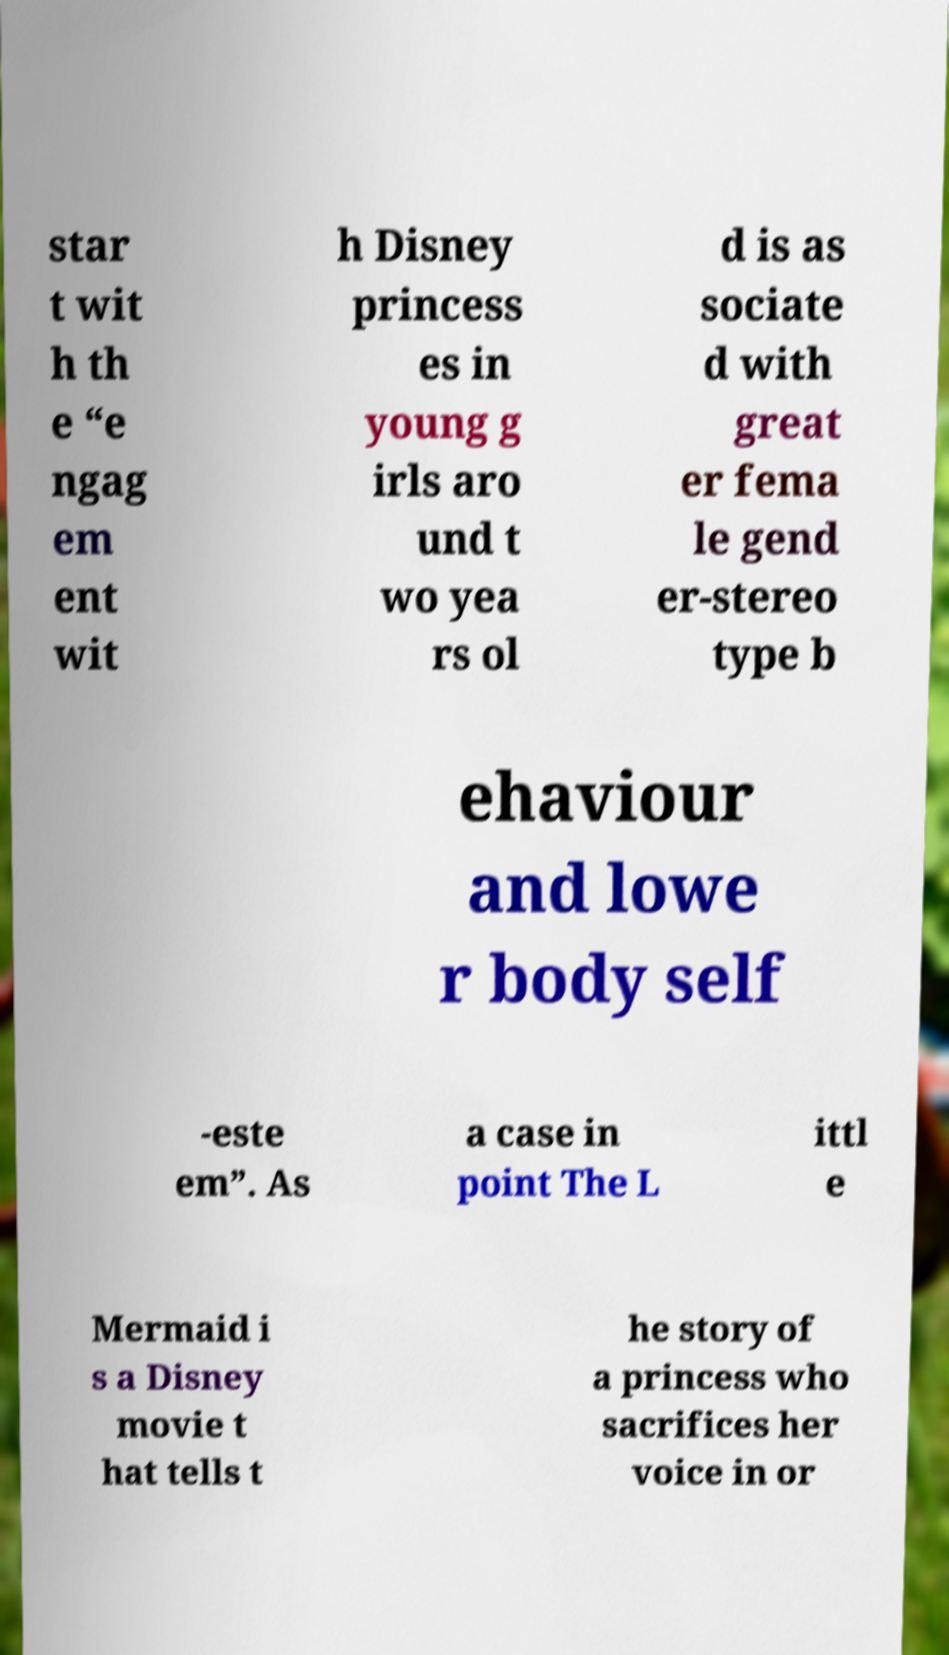Could you extract and type out the text from this image? star t wit h th e “e ngag em ent wit h Disney princess es in young g irls aro und t wo yea rs ol d is as sociate d with great er fema le gend er-stereo type b ehaviour and lowe r body self -este em”. As a case in point The L ittl e Mermaid i s a Disney movie t hat tells t he story of a princess who sacrifices her voice in or 